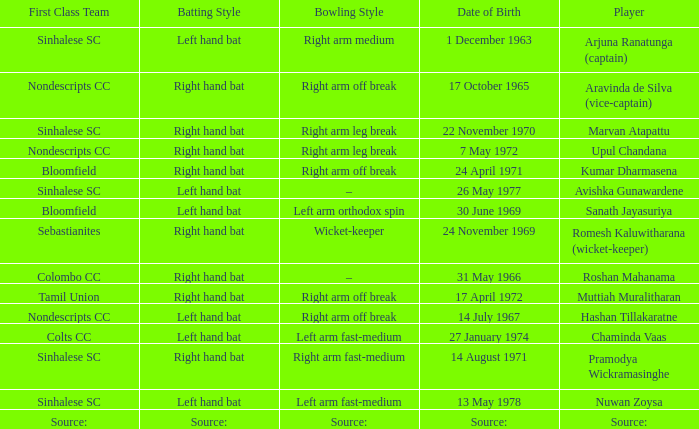What first class team does sanath jayasuriya play for? Bloomfield. 